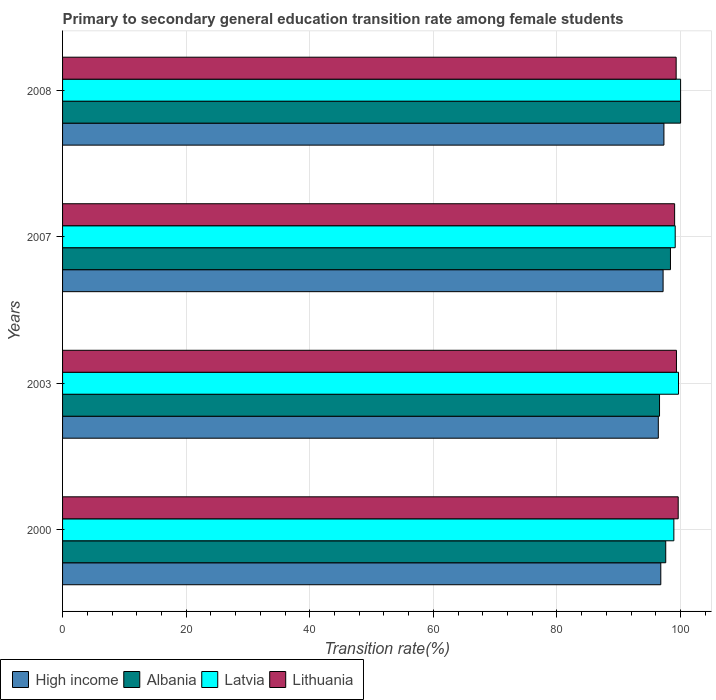How many different coloured bars are there?
Your answer should be compact. 4. How many groups of bars are there?
Offer a very short reply. 4. Are the number of bars per tick equal to the number of legend labels?
Your response must be concise. Yes. Are the number of bars on each tick of the Y-axis equal?
Provide a short and direct response. Yes. How many bars are there on the 1st tick from the top?
Your answer should be compact. 4. In how many cases, is the number of bars for a given year not equal to the number of legend labels?
Provide a short and direct response. 0. What is the transition rate in Albania in 2000?
Give a very brief answer. 97.6. Across all years, what is the maximum transition rate in High income?
Your answer should be compact. 97.3. Across all years, what is the minimum transition rate in High income?
Give a very brief answer. 96.4. What is the total transition rate in Lithuania in the graph?
Your answer should be very brief. 397.26. What is the difference between the transition rate in Albania in 2000 and that in 2008?
Keep it short and to the point. -2.4. What is the difference between the transition rate in Lithuania in 2008 and the transition rate in High income in 2007?
Your response must be concise. 2.11. What is the average transition rate in Albania per year?
Your answer should be compact. 98.14. In the year 2008, what is the difference between the transition rate in Lithuania and transition rate in Albania?
Keep it short and to the point. -0.72. What is the ratio of the transition rate in Lithuania in 2003 to that in 2008?
Give a very brief answer. 1. Is the transition rate in High income in 2000 less than that in 2008?
Offer a terse response. Yes. What is the difference between the highest and the second highest transition rate in Latvia?
Your answer should be compact. 0.34. What is the difference between the highest and the lowest transition rate in High income?
Make the answer very short. 0.91. In how many years, is the transition rate in Albania greater than the average transition rate in Albania taken over all years?
Give a very brief answer. 2. Is the sum of the transition rate in High income in 2003 and 2007 greater than the maximum transition rate in Albania across all years?
Provide a short and direct response. Yes. Is it the case that in every year, the sum of the transition rate in Latvia and transition rate in Albania is greater than the sum of transition rate in Lithuania and transition rate in High income?
Your answer should be compact. No. What does the 2nd bar from the top in 2008 represents?
Offer a terse response. Latvia. Is it the case that in every year, the sum of the transition rate in Latvia and transition rate in Lithuania is greater than the transition rate in Albania?
Offer a terse response. Yes. How many bars are there?
Offer a terse response. 16. Are all the bars in the graph horizontal?
Your answer should be very brief. Yes. Does the graph contain any zero values?
Your answer should be very brief. No. What is the title of the graph?
Offer a terse response. Primary to secondary general education transition rate among female students. What is the label or title of the X-axis?
Your answer should be compact. Transition rate(%). What is the Transition rate(%) of High income in 2000?
Your response must be concise. 96.8. What is the Transition rate(%) in Albania in 2000?
Make the answer very short. 97.6. What is the Transition rate(%) in Latvia in 2000?
Provide a succinct answer. 98.91. What is the Transition rate(%) of Lithuania in 2000?
Make the answer very short. 99.61. What is the Transition rate(%) in High income in 2003?
Offer a terse response. 96.4. What is the Transition rate(%) in Albania in 2003?
Keep it short and to the point. 96.59. What is the Transition rate(%) in Latvia in 2003?
Your response must be concise. 99.66. What is the Transition rate(%) of Lithuania in 2003?
Your answer should be compact. 99.33. What is the Transition rate(%) in High income in 2007?
Offer a very short reply. 97.17. What is the Transition rate(%) of Albania in 2007?
Offer a very short reply. 98.36. What is the Transition rate(%) of Latvia in 2007?
Provide a succinct answer. 99.13. What is the Transition rate(%) of Lithuania in 2007?
Provide a succinct answer. 99.03. What is the Transition rate(%) in High income in 2008?
Provide a short and direct response. 97.3. What is the Transition rate(%) of Latvia in 2008?
Offer a terse response. 100. What is the Transition rate(%) in Lithuania in 2008?
Offer a very short reply. 99.28. Across all years, what is the maximum Transition rate(%) of High income?
Your answer should be very brief. 97.3. Across all years, what is the maximum Transition rate(%) in Albania?
Ensure brevity in your answer.  100. Across all years, what is the maximum Transition rate(%) in Lithuania?
Your answer should be very brief. 99.61. Across all years, what is the minimum Transition rate(%) of High income?
Make the answer very short. 96.4. Across all years, what is the minimum Transition rate(%) of Albania?
Offer a terse response. 96.59. Across all years, what is the minimum Transition rate(%) of Latvia?
Provide a short and direct response. 98.91. Across all years, what is the minimum Transition rate(%) of Lithuania?
Make the answer very short. 99.03. What is the total Transition rate(%) in High income in the graph?
Your answer should be compact. 387.67. What is the total Transition rate(%) in Albania in the graph?
Offer a very short reply. 392.55. What is the total Transition rate(%) of Latvia in the graph?
Offer a very short reply. 397.7. What is the total Transition rate(%) in Lithuania in the graph?
Provide a short and direct response. 397.26. What is the difference between the Transition rate(%) of High income in 2000 and that in 2003?
Offer a very short reply. 0.4. What is the difference between the Transition rate(%) in Albania in 2000 and that in 2003?
Provide a short and direct response. 1. What is the difference between the Transition rate(%) of Latvia in 2000 and that in 2003?
Provide a succinct answer. -0.75. What is the difference between the Transition rate(%) in Lithuania in 2000 and that in 2003?
Give a very brief answer. 0.28. What is the difference between the Transition rate(%) in High income in 2000 and that in 2007?
Ensure brevity in your answer.  -0.37. What is the difference between the Transition rate(%) in Albania in 2000 and that in 2007?
Ensure brevity in your answer.  -0.77. What is the difference between the Transition rate(%) of Latvia in 2000 and that in 2007?
Ensure brevity in your answer.  -0.22. What is the difference between the Transition rate(%) in Lithuania in 2000 and that in 2007?
Keep it short and to the point. 0.58. What is the difference between the Transition rate(%) of High income in 2000 and that in 2008?
Make the answer very short. -0.51. What is the difference between the Transition rate(%) in Albania in 2000 and that in 2008?
Provide a succinct answer. -2.4. What is the difference between the Transition rate(%) in Latvia in 2000 and that in 2008?
Your answer should be very brief. -1.09. What is the difference between the Transition rate(%) in Lithuania in 2000 and that in 2008?
Your answer should be very brief. 0.33. What is the difference between the Transition rate(%) of High income in 2003 and that in 2007?
Make the answer very short. -0.77. What is the difference between the Transition rate(%) in Albania in 2003 and that in 2007?
Give a very brief answer. -1.77. What is the difference between the Transition rate(%) of Latvia in 2003 and that in 2007?
Offer a very short reply. 0.54. What is the difference between the Transition rate(%) in Lithuania in 2003 and that in 2007?
Offer a very short reply. 0.3. What is the difference between the Transition rate(%) of High income in 2003 and that in 2008?
Your response must be concise. -0.91. What is the difference between the Transition rate(%) in Albania in 2003 and that in 2008?
Provide a short and direct response. -3.41. What is the difference between the Transition rate(%) in Latvia in 2003 and that in 2008?
Ensure brevity in your answer.  -0.34. What is the difference between the Transition rate(%) of Lithuania in 2003 and that in 2008?
Offer a terse response. 0.05. What is the difference between the Transition rate(%) of High income in 2007 and that in 2008?
Provide a short and direct response. -0.14. What is the difference between the Transition rate(%) in Albania in 2007 and that in 2008?
Offer a terse response. -1.64. What is the difference between the Transition rate(%) in Latvia in 2007 and that in 2008?
Offer a very short reply. -0.87. What is the difference between the Transition rate(%) of Lithuania in 2007 and that in 2008?
Give a very brief answer. -0.25. What is the difference between the Transition rate(%) of High income in 2000 and the Transition rate(%) of Albania in 2003?
Provide a short and direct response. 0.2. What is the difference between the Transition rate(%) of High income in 2000 and the Transition rate(%) of Latvia in 2003?
Your answer should be compact. -2.87. What is the difference between the Transition rate(%) in High income in 2000 and the Transition rate(%) in Lithuania in 2003?
Provide a succinct answer. -2.53. What is the difference between the Transition rate(%) in Albania in 2000 and the Transition rate(%) in Latvia in 2003?
Provide a succinct answer. -2.07. What is the difference between the Transition rate(%) in Albania in 2000 and the Transition rate(%) in Lithuania in 2003?
Offer a very short reply. -1.74. What is the difference between the Transition rate(%) in Latvia in 2000 and the Transition rate(%) in Lithuania in 2003?
Your answer should be very brief. -0.42. What is the difference between the Transition rate(%) in High income in 2000 and the Transition rate(%) in Albania in 2007?
Your answer should be very brief. -1.56. What is the difference between the Transition rate(%) of High income in 2000 and the Transition rate(%) of Latvia in 2007?
Keep it short and to the point. -2.33. What is the difference between the Transition rate(%) in High income in 2000 and the Transition rate(%) in Lithuania in 2007?
Provide a succinct answer. -2.24. What is the difference between the Transition rate(%) of Albania in 2000 and the Transition rate(%) of Latvia in 2007?
Keep it short and to the point. -1.53. What is the difference between the Transition rate(%) in Albania in 2000 and the Transition rate(%) in Lithuania in 2007?
Your response must be concise. -1.44. What is the difference between the Transition rate(%) of Latvia in 2000 and the Transition rate(%) of Lithuania in 2007?
Ensure brevity in your answer.  -0.12. What is the difference between the Transition rate(%) of High income in 2000 and the Transition rate(%) of Albania in 2008?
Keep it short and to the point. -3.2. What is the difference between the Transition rate(%) in High income in 2000 and the Transition rate(%) in Latvia in 2008?
Your answer should be compact. -3.2. What is the difference between the Transition rate(%) in High income in 2000 and the Transition rate(%) in Lithuania in 2008?
Provide a short and direct response. -2.49. What is the difference between the Transition rate(%) in Albania in 2000 and the Transition rate(%) in Latvia in 2008?
Provide a succinct answer. -2.4. What is the difference between the Transition rate(%) of Albania in 2000 and the Transition rate(%) of Lithuania in 2008?
Your answer should be very brief. -1.69. What is the difference between the Transition rate(%) of Latvia in 2000 and the Transition rate(%) of Lithuania in 2008?
Give a very brief answer. -0.37. What is the difference between the Transition rate(%) of High income in 2003 and the Transition rate(%) of Albania in 2007?
Offer a terse response. -1.97. What is the difference between the Transition rate(%) of High income in 2003 and the Transition rate(%) of Latvia in 2007?
Provide a short and direct response. -2.73. What is the difference between the Transition rate(%) of High income in 2003 and the Transition rate(%) of Lithuania in 2007?
Offer a terse response. -2.64. What is the difference between the Transition rate(%) in Albania in 2003 and the Transition rate(%) in Latvia in 2007?
Give a very brief answer. -2.54. What is the difference between the Transition rate(%) of Albania in 2003 and the Transition rate(%) of Lithuania in 2007?
Give a very brief answer. -2.44. What is the difference between the Transition rate(%) of Latvia in 2003 and the Transition rate(%) of Lithuania in 2007?
Give a very brief answer. 0.63. What is the difference between the Transition rate(%) in High income in 2003 and the Transition rate(%) in Albania in 2008?
Ensure brevity in your answer.  -3.6. What is the difference between the Transition rate(%) of High income in 2003 and the Transition rate(%) of Latvia in 2008?
Your answer should be compact. -3.6. What is the difference between the Transition rate(%) of High income in 2003 and the Transition rate(%) of Lithuania in 2008?
Give a very brief answer. -2.89. What is the difference between the Transition rate(%) of Albania in 2003 and the Transition rate(%) of Latvia in 2008?
Ensure brevity in your answer.  -3.41. What is the difference between the Transition rate(%) of Albania in 2003 and the Transition rate(%) of Lithuania in 2008?
Offer a terse response. -2.69. What is the difference between the Transition rate(%) of Latvia in 2003 and the Transition rate(%) of Lithuania in 2008?
Make the answer very short. 0.38. What is the difference between the Transition rate(%) in High income in 2007 and the Transition rate(%) in Albania in 2008?
Your answer should be very brief. -2.83. What is the difference between the Transition rate(%) in High income in 2007 and the Transition rate(%) in Latvia in 2008?
Your answer should be compact. -2.83. What is the difference between the Transition rate(%) of High income in 2007 and the Transition rate(%) of Lithuania in 2008?
Keep it short and to the point. -2.11. What is the difference between the Transition rate(%) in Albania in 2007 and the Transition rate(%) in Latvia in 2008?
Your answer should be very brief. -1.64. What is the difference between the Transition rate(%) in Albania in 2007 and the Transition rate(%) in Lithuania in 2008?
Offer a terse response. -0.92. What is the difference between the Transition rate(%) in Latvia in 2007 and the Transition rate(%) in Lithuania in 2008?
Make the answer very short. -0.15. What is the average Transition rate(%) in High income per year?
Your response must be concise. 96.92. What is the average Transition rate(%) of Albania per year?
Make the answer very short. 98.14. What is the average Transition rate(%) of Latvia per year?
Keep it short and to the point. 99.43. What is the average Transition rate(%) of Lithuania per year?
Your response must be concise. 99.32. In the year 2000, what is the difference between the Transition rate(%) in High income and Transition rate(%) in Albania?
Provide a short and direct response. -0.8. In the year 2000, what is the difference between the Transition rate(%) in High income and Transition rate(%) in Latvia?
Provide a short and direct response. -2.11. In the year 2000, what is the difference between the Transition rate(%) in High income and Transition rate(%) in Lithuania?
Provide a short and direct response. -2.82. In the year 2000, what is the difference between the Transition rate(%) in Albania and Transition rate(%) in Latvia?
Give a very brief answer. -1.32. In the year 2000, what is the difference between the Transition rate(%) of Albania and Transition rate(%) of Lithuania?
Your answer should be very brief. -2.02. In the year 2000, what is the difference between the Transition rate(%) of Latvia and Transition rate(%) of Lithuania?
Offer a very short reply. -0.7. In the year 2003, what is the difference between the Transition rate(%) of High income and Transition rate(%) of Albania?
Offer a terse response. -0.2. In the year 2003, what is the difference between the Transition rate(%) in High income and Transition rate(%) in Latvia?
Your answer should be very brief. -3.27. In the year 2003, what is the difference between the Transition rate(%) of High income and Transition rate(%) of Lithuania?
Your answer should be compact. -2.94. In the year 2003, what is the difference between the Transition rate(%) of Albania and Transition rate(%) of Latvia?
Offer a very short reply. -3.07. In the year 2003, what is the difference between the Transition rate(%) of Albania and Transition rate(%) of Lithuania?
Provide a short and direct response. -2.74. In the year 2003, what is the difference between the Transition rate(%) of Latvia and Transition rate(%) of Lithuania?
Make the answer very short. 0.33. In the year 2007, what is the difference between the Transition rate(%) in High income and Transition rate(%) in Albania?
Keep it short and to the point. -1.19. In the year 2007, what is the difference between the Transition rate(%) of High income and Transition rate(%) of Latvia?
Give a very brief answer. -1.96. In the year 2007, what is the difference between the Transition rate(%) in High income and Transition rate(%) in Lithuania?
Provide a succinct answer. -1.86. In the year 2007, what is the difference between the Transition rate(%) in Albania and Transition rate(%) in Latvia?
Give a very brief answer. -0.77. In the year 2007, what is the difference between the Transition rate(%) in Albania and Transition rate(%) in Lithuania?
Give a very brief answer. -0.67. In the year 2007, what is the difference between the Transition rate(%) of Latvia and Transition rate(%) of Lithuania?
Give a very brief answer. 0.1. In the year 2008, what is the difference between the Transition rate(%) in High income and Transition rate(%) in Albania?
Your answer should be compact. -2.7. In the year 2008, what is the difference between the Transition rate(%) in High income and Transition rate(%) in Latvia?
Your response must be concise. -2.7. In the year 2008, what is the difference between the Transition rate(%) in High income and Transition rate(%) in Lithuania?
Give a very brief answer. -1.98. In the year 2008, what is the difference between the Transition rate(%) in Albania and Transition rate(%) in Latvia?
Offer a terse response. 0. In the year 2008, what is the difference between the Transition rate(%) of Albania and Transition rate(%) of Lithuania?
Give a very brief answer. 0.72. In the year 2008, what is the difference between the Transition rate(%) in Latvia and Transition rate(%) in Lithuania?
Make the answer very short. 0.72. What is the ratio of the Transition rate(%) in High income in 2000 to that in 2003?
Give a very brief answer. 1. What is the ratio of the Transition rate(%) of Albania in 2000 to that in 2003?
Your answer should be compact. 1.01. What is the ratio of the Transition rate(%) of Albania in 2000 to that in 2007?
Provide a succinct answer. 0.99. What is the ratio of the Transition rate(%) in Lithuania in 2000 to that in 2007?
Provide a short and direct response. 1.01. What is the ratio of the Transition rate(%) of Albania in 2000 to that in 2008?
Ensure brevity in your answer.  0.98. What is the ratio of the Transition rate(%) in Lithuania in 2000 to that in 2008?
Make the answer very short. 1. What is the ratio of the Transition rate(%) of High income in 2003 to that in 2007?
Ensure brevity in your answer.  0.99. What is the ratio of the Transition rate(%) in Albania in 2003 to that in 2007?
Offer a terse response. 0.98. What is the ratio of the Transition rate(%) of Latvia in 2003 to that in 2007?
Your answer should be compact. 1.01. What is the ratio of the Transition rate(%) of Albania in 2003 to that in 2008?
Ensure brevity in your answer.  0.97. What is the ratio of the Transition rate(%) of High income in 2007 to that in 2008?
Provide a succinct answer. 1. What is the ratio of the Transition rate(%) in Albania in 2007 to that in 2008?
Your answer should be very brief. 0.98. What is the ratio of the Transition rate(%) of Latvia in 2007 to that in 2008?
Give a very brief answer. 0.99. What is the ratio of the Transition rate(%) of Lithuania in 2007 to that in 2008?
Your response must be concise. 1. What is the difference between the highest and the second highest Transition rate(%) in High income?
Provide a short and direct response. 0.14. What is the difference between the highest and the second highest Transition rate(%) in Albania?
Your answer should be compact. 1.64. What is the difference between the highest and the second highest Transition rate(%) of Latvia?
Give a very brief answer. 0.34. What is the difference between the highest and the second highest Transition rate(%) of Lithuania?
Keep it short and to the point. 0.28. What is the difference between the highest and the lowest Transition rate(%) of High income?
Provide a short and direct response. 0.91. What is the difference between the highest and the lowest Transition rate(%) in Albania?
Provide a short and direct response. 3.41. What is the difference between the highest and the lowest Transition rate(%) in Latvia?
Give a very brief answer. 1.09. What is the difference between the highest and the lowest Transition rate(%) of Lithuania?
Make the answer very short. 0.58. 